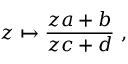Convert formula to latex. <formula><loc_0><loc_0><loc_500><loc_500>z \mapsto { \frac { z a + b } { z c + d } } \ ,</formula> 